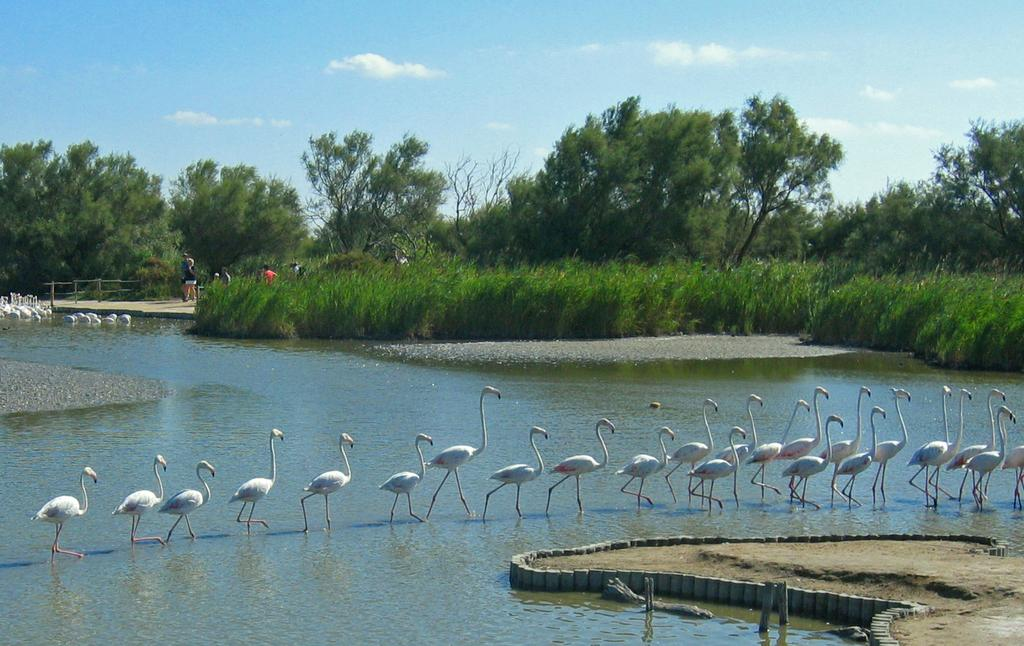What animals are present in the image? There are many ducks in the image. How are the ducks positioned in the image? The ducks are walking one after the other. What can be seen in the background of the image? There are trees and the sky visible in the background of the image. Where can the girls be seen applying glue in the image? There are no girls or glue present in the image; it features many ducks walking one after the other. 